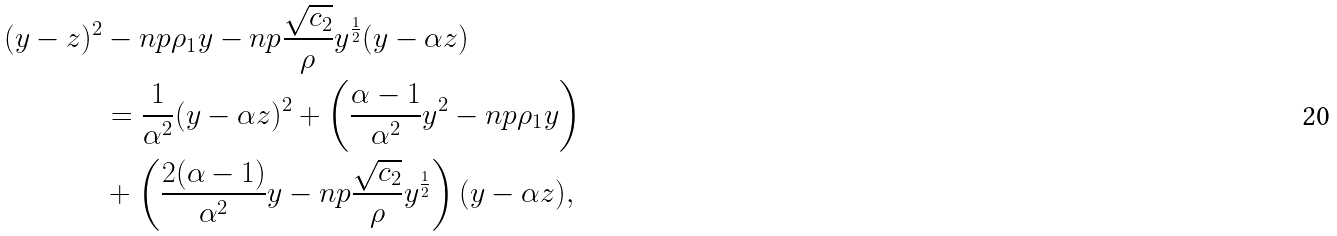Convert formula to latex. <formula><loc_0><loc_0><loc_500><loc_500>( y - z ) ^ { 2 } & - n p \rho _ { 1 } y - n p \frac { \sqrt { c _ { 2 } } } { \rho } y ^ { \frac { 1 } { 2 } } ( y - \alpha z ) \\ & = \frac { 1 } { \alpha ^ { 2 } } ( y - \alpha z ) ^ { 2 } + \left ( \frac { \alpha - 1 } { \alpha ^ { 2 } } y ^ { 2 } - n p \rho _ { 1 } y \right ) \\ & + \left ( \frac { 2 ( \alpha - 1 ) } { \alpha ^ { 2 } } y - n p \frac { \sqrt { c _ { 2 } } } { \rho } y ^ { \frac { 1 } { 2 } } \right ) ( y - \alpha z ) ,</formula> 